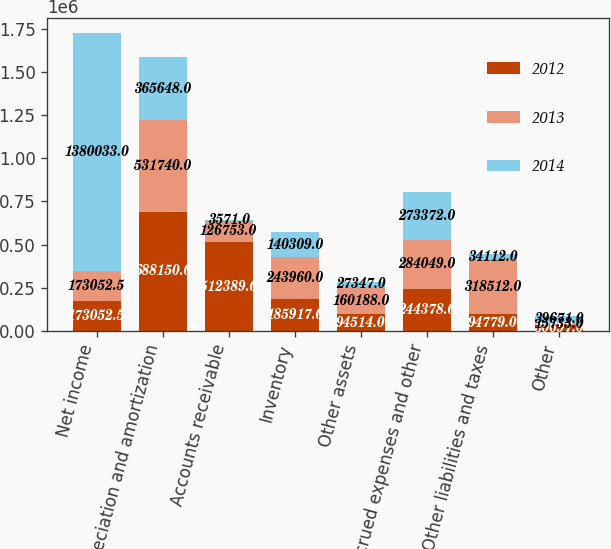<chart> <loc_0><loc_0><loc_500><loc_500><stacked_bar_chart><ecel><fcel>Net income<fcel>Depreciation and amortization<fcel>Accounts receivable<fcel>Inventory<fcel>Other assets<fcel>Accrued expenses and other<fcel>Other liabilities and taxes<fcel>Other<nl><fcel>2012<fcel>173052<fcel>688150<fcel>512389<fcel>185917<fcel>94514<fcel>244378<fcel>94779<fcel>30697<nl><fcel>2013<fcel>173052<fcel>531740<fcel>126753<fcel>243960<fcel>160188<fcel>284049<fcel>318512<fcel>15733<nl><fcel>2014<fcel>1.38003e+06<fcel>365648<fcel>3571<fcel>140309<fcel>27347<fcel>273372<fcel>34112<fcel>39671<nl></chart> 